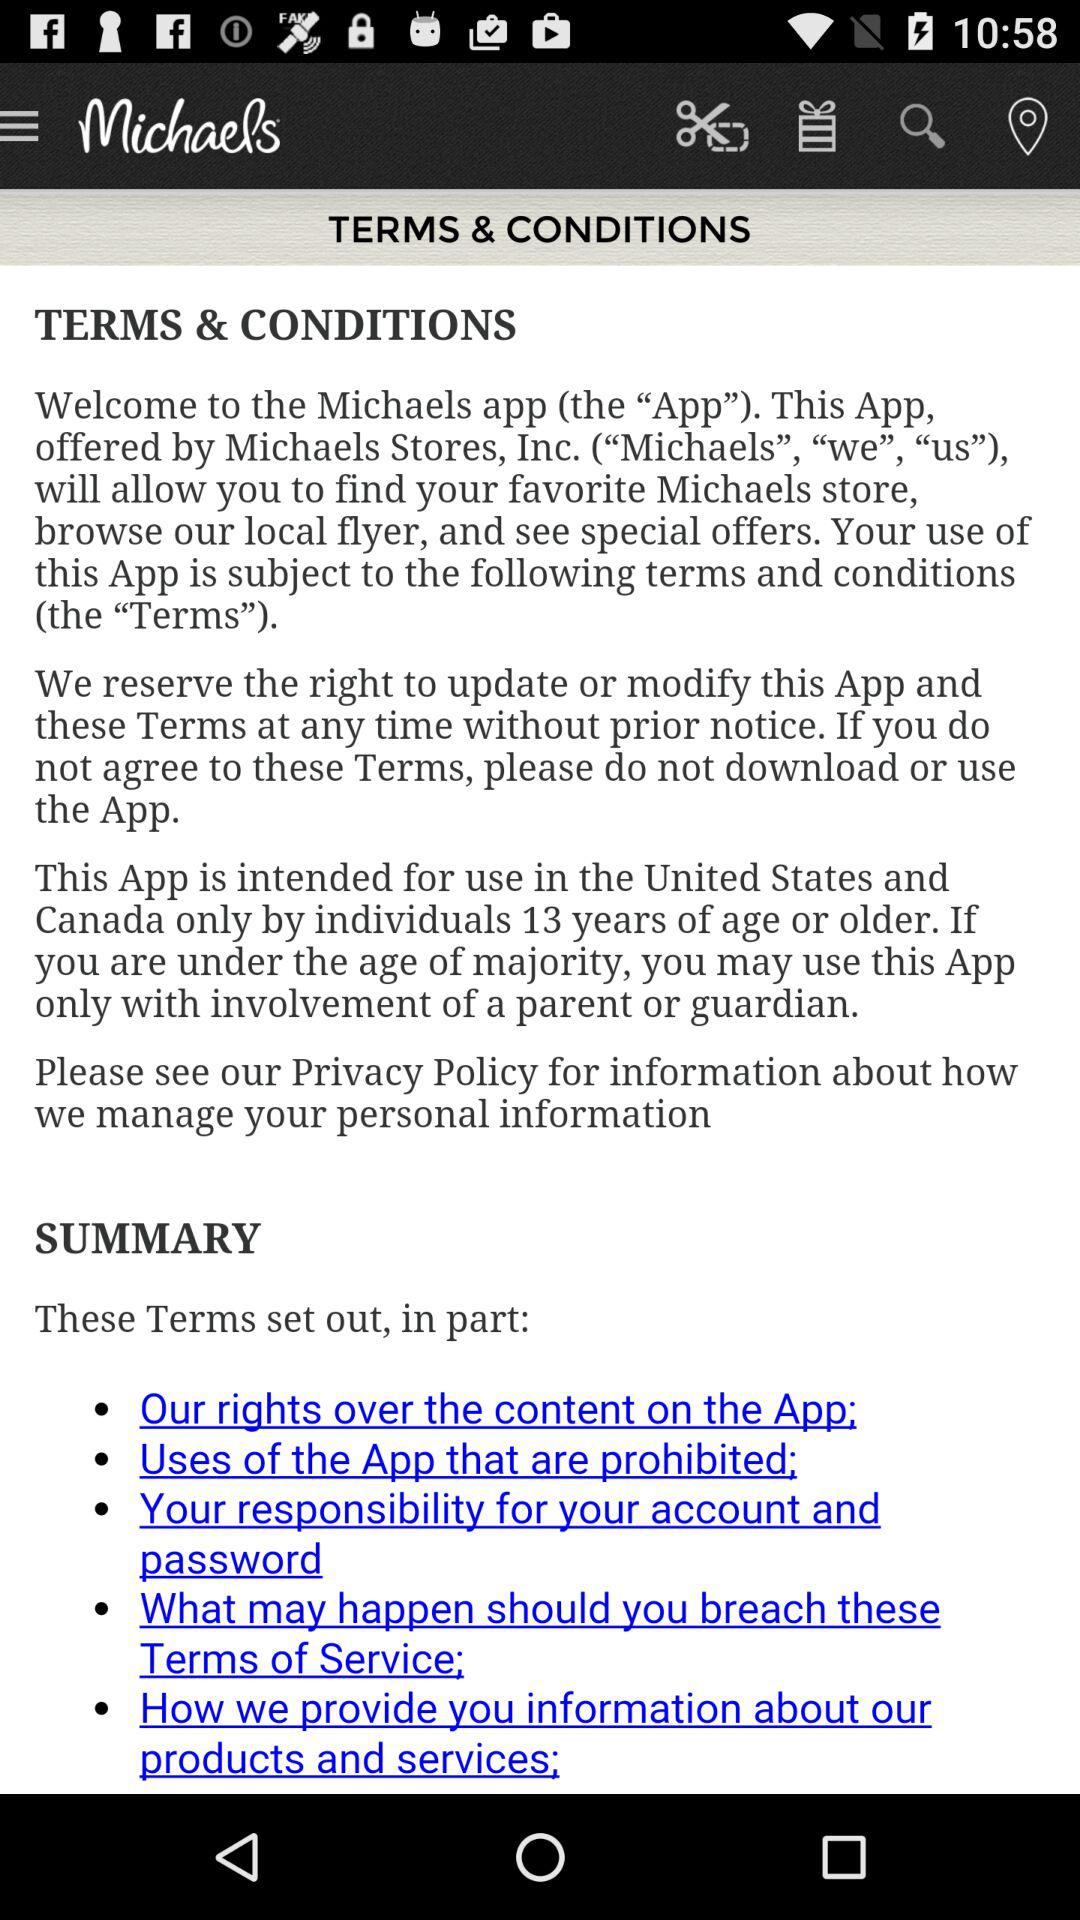What is the minimum age to use this app? The minimum age to use this app is 13. 